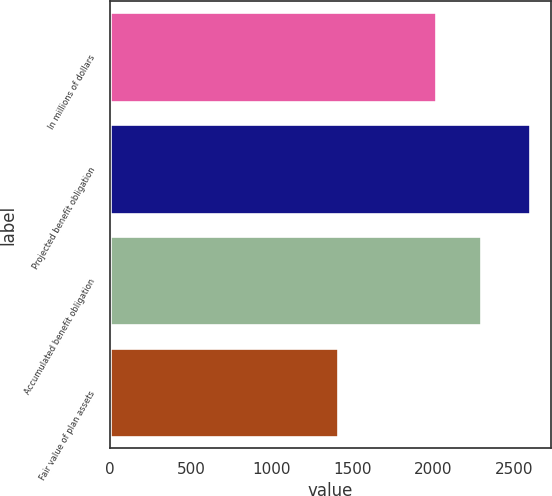Convert chart. <chart><loc_0><loc_0><loc_500><loc_500><bar_chart><fcel>In millions of dollars<fcel>Projected benefit obligation<fcel>Accumulated benefit obligation<fcel>Fair value of plan assets<nl><fcel>2017<fcel>2596<fcel>2296<fcel>1407<nl></chart> 